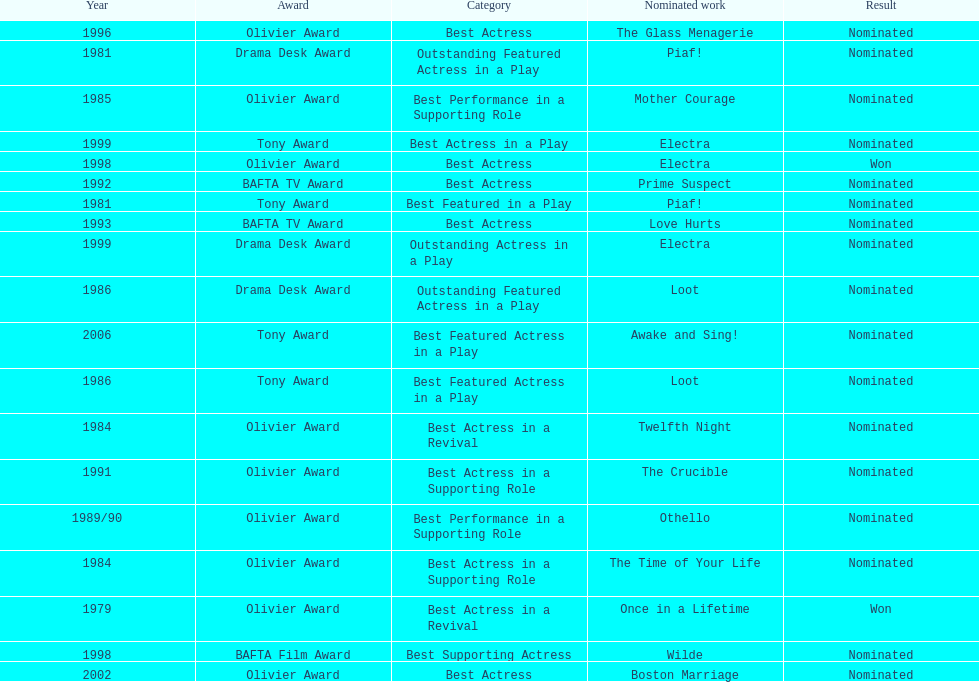What award did once in a lifetime win? Best Actress in a Revival. 